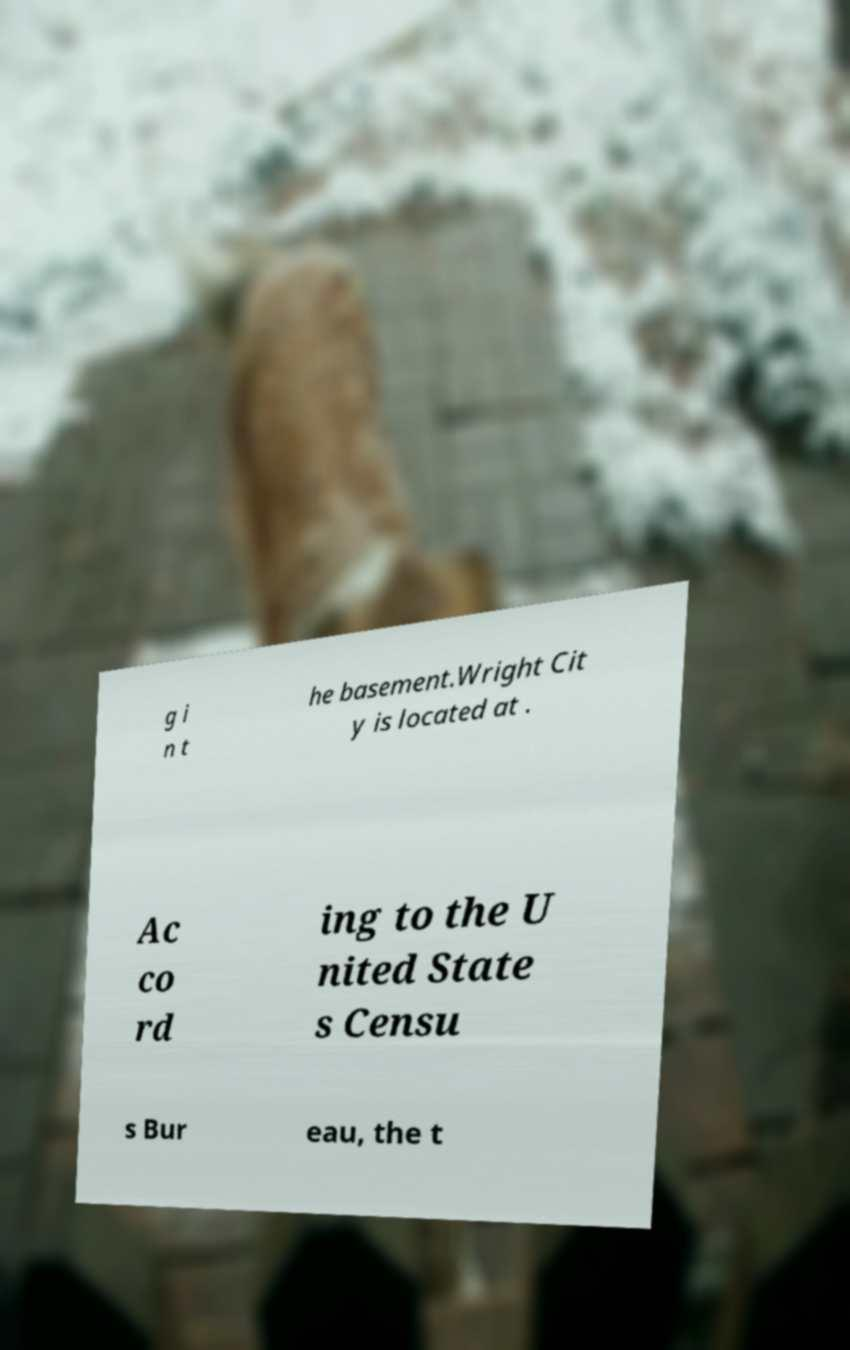Please identify and transcribe the text found in this image. g i n t he basement.Wright Cit y is located at . Ac co rd ing to the U nited State s Censu s Bur eau, the t 